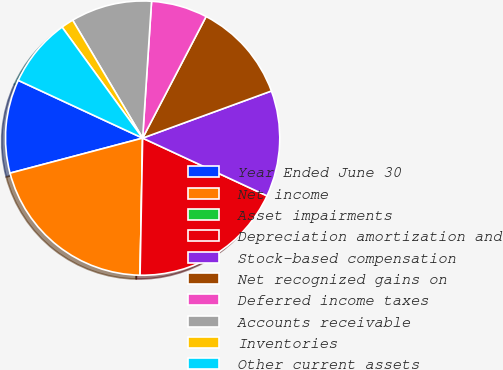Convert chart. <chart><loc_0><loc_0><loc_500><loc_500><pie_chart><fcel>Year Ended June 30<fcel>Net income<fcel>Asset impairments<fcel>Depreciation amortization and<fcel>Stock-based compensation<fcel>Net recognized gains on<fcel>Deferred income taxes<fcel>Accounts receivable<fcel>Inventories<fcel>Other current assets<nl><fcel>11.03%<fcel>20.59%<fcel>0.0%<fcel>18.38%<fcel>12.5%<fcel>11.76%<fcel>6.62%<fcel>9.56%<fcel>1.47%<fcel>8.09%<nl></chart> 